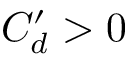Convert formula to latex. <formula><loc_0><loc_0><loc_500><loc_500>C _ { d } ^ { \prime } > 0</formula> 